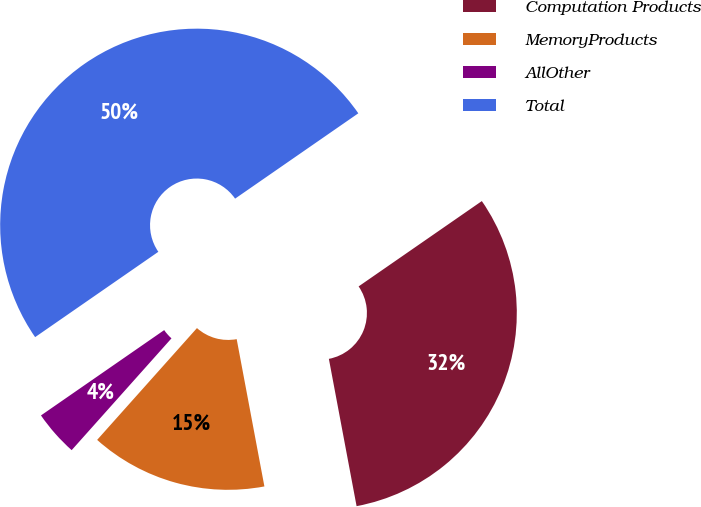<chart> <loc_0><loc_0><loc_500><loc_500><pie_chart><fcel>Computation Products<fcel>MemoryProducts<fcel>AllOther<fcel>Total<nl><fcel>31.68%<fcel>14.56%<fcel>3.76%<fcel>50.0%<nl></chart> 